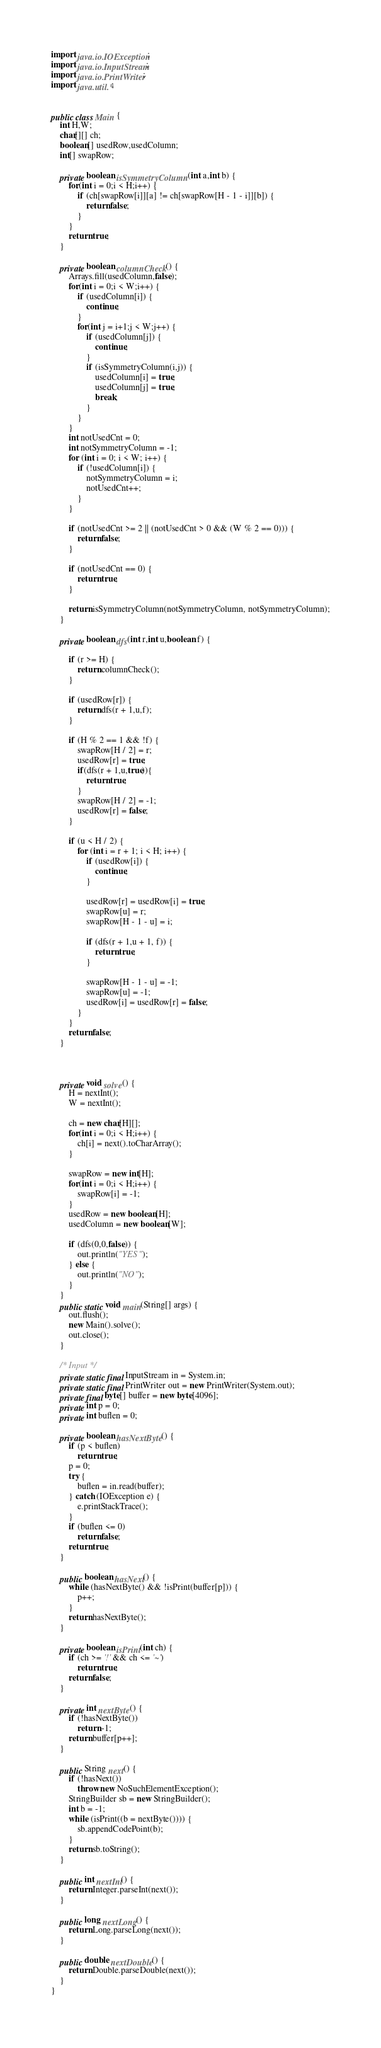Convert code to text. <code><loc_0><loc_0><loc_500><loc_500><_Java_>import java.io.IOException;
import java.io.InputStream;
import java.io.PrintWriter;
import java.util.*;


public class Main {
    int H,W;
    char[][] ch;
    boolean[] usedRow,usedColumn;
    int[] swapRow;

    private boolean isSymmetryColumn(int a,int b) {
        for(int i = 0;i < H;i++) {
            if (ch[swapRow[i]][a] != ch[swapRow[H - 1 - i]][b]) {
                return false;
            }
        }
        return true;
    }

    private boolean columnCheck() {
        Arrays.fill(usedColumn,false);
        for(int i = 0;i < W;i++) {
            if (usedColumn[i]) {
                continue;
            }
            for(int j = i+1;j < W;j++) {
                if (usedColumn[j]) {
                    continue;
                }
                if (isSymmetryColumn(i,j)) {
                    usedColumn[i] = true;
                    usedColumn[j] = true;
                    break;
                }
            }
        }
        int notUsedCnt = 0;
        int notSymmetryColumn = -1;
        for (int i = 0; i < W; i++) {
            if (!usedColumn[i]) {
                notSymmetryColumn = i;
                notUsedCnt++;
            }
        }

        if (notUsedCnt >= 2 || (notUsedCnt > 0 && (W % 2 == 0))) {
            return false;
        }

        if (notUsedCnt == 0) {
            return true;
        }

        return isSymmetryColumn(notSymmetryColumn, notSymmetryColumn);
    }

    private boolean dfs(int r,int u,boolean f) {

        if (r >= H) {
            return columnCheck();
        }

        if (usedRow[r]) {
            return dfs(r + 1,u,f);
        }

        if (H % 2 == 1 && !f) {
            swapRow[H / 2] = r;
            usedRow[r] = true;
            if(dfs(r + 1,u,true)){
                return true;
            }
            swapRow[H / 2] = -1;
            usedRow[r] = false;
        }

        if (u < H / 2) {
            for (int i = r + 1; i < H; i++) {
                if (usedRow[i]) {
                    continue;
                }

                usedRow[r] = usedRow[i] = true;
                swapRow[u] = r;
                swapRow[H - 1 - u] = i;

                if (dfs(r + 1,u + 1, f)) {
                    return true;
                }

                swapRow[H - 1 - u] = -1;
                swapRow[u] = -1;
                usedRow[i] = usedRow[r] = false;
            }
        }
        return false;
    }



    private void solve() {
        H = nextInt();
        W = nextInt();

        ch = new char[H][];
        for(int i = 0;i < H;i++) {
            ch[i] = next().toCharArray();
        }

        swapRow = new int[H];
        for(int i = 0;i < H;i++) {
            swapRow[i] = -1;
        }
        usedRow = new boolean[H];
        usedColumn = new boolean[W];

        if (dfs(0,0,false)) {
            out.println("YES");
        } else {
            out.println("NO");
        }
    }
    public static void main(String[] args) {
        out.flush();
        new Main().solve();
        out.close();
    }

    /* Input */
    private static final InputStream in = System.in;
    private static final PrintWriter out = new PrintWriter(System.out);
    private final byte[] buffer = new byte[4096];
    private int p = 0;
    private int buflen = 0;

    private boolean hasNextByte() {
        if (p < buflen)
            return true;
        p = 0;
        try {
            buflen = in.read(buffer);
        } catch (IOException e) {
            e.printStackTrace();
        }
        if (buflen <= 0)
            return false;
        return true;
    }

    public boolean hasNext() {
        while (hasNextByte() && !isPrint(buffer[p])) {
            p++;
        }
        return hasNextByte();
    }

    private boolean isPrint(int ch) {
        if (ch >= '!' && ch <= '~')
            return true;
        return false;
    }

    private int nextByte() {
        if (!hasNextByte())
            return -1;
        return buffer[p++];
    }

    public String next() {
        if (!hasNext())
            throw new NoSuchElementException();
        StringBuilder sb = new StringBuilder();
        int b = -1;
        while (isPrint((b = nextByte()))) {
            sb.appendCodePoint(b);
        }
        return sb.toString();
    }

    public int nextInt() {
        return Integer.parseInt(next());
    }

    public long nextLong() {
        return Long.parseLong(next());
    }

    public double nextDouble() {
        return Double.parseDouble(next());
    }
}
</code> 